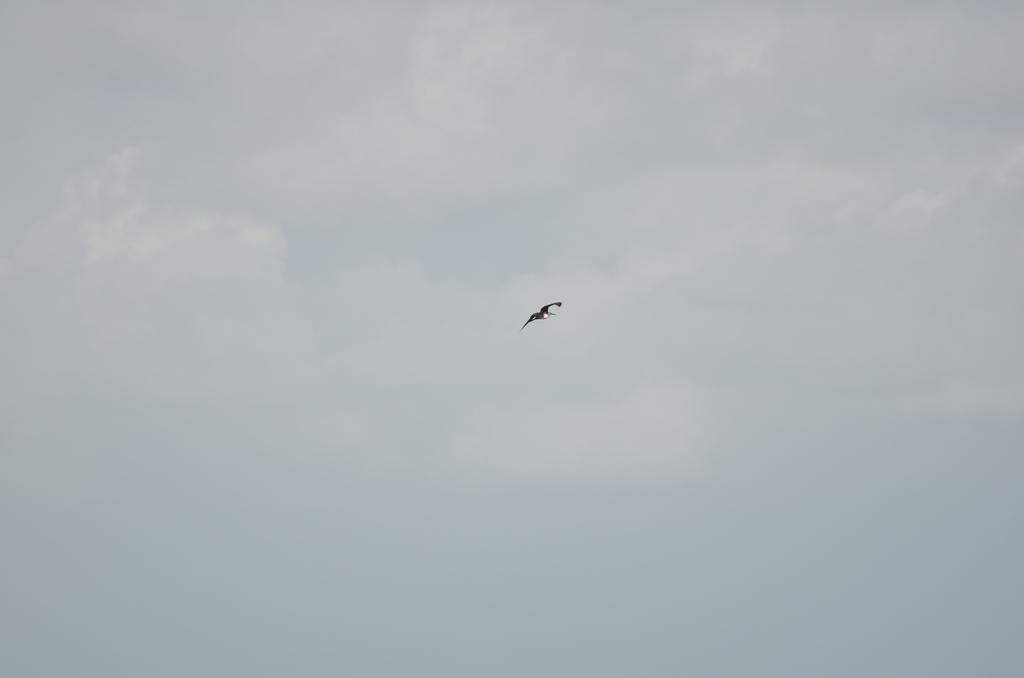How would you summarize this image in a sentence or two? In this picture I can see a bird which is in the middle of picture and I see the sky in the background. 